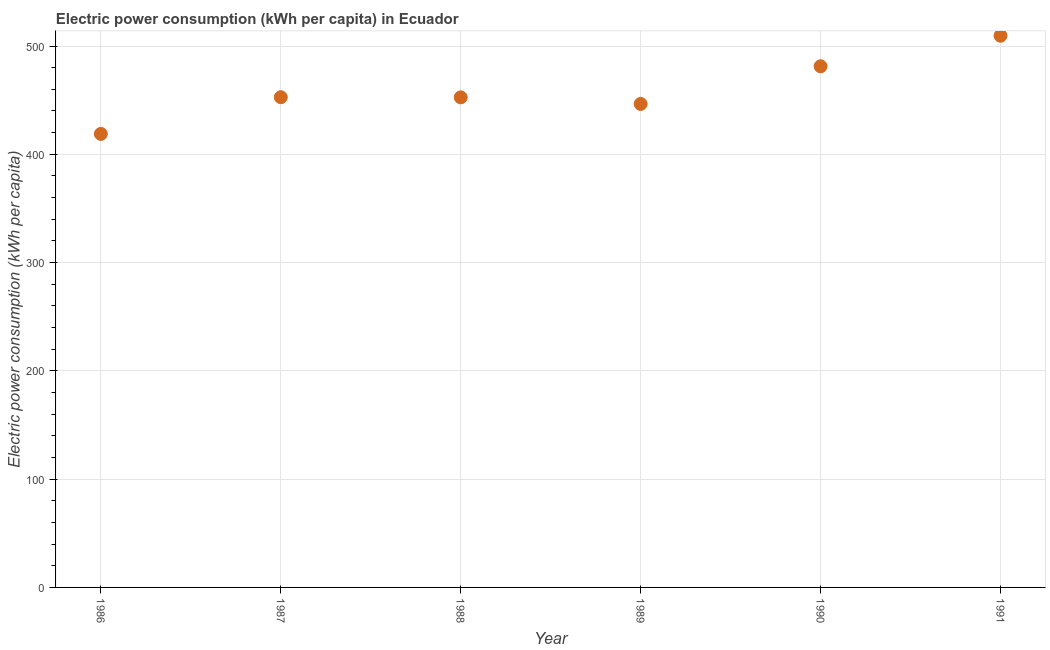What is the electric power consumption in 1990?
Provide a short and direct response. 481.3. Across all years, what is the maximum electric power consumption?
Your answer should be compact. 509.51. Across all years, what is the minimum electric power consumption?
Offer a very short reply. 418.85. In which year was the electric power consumption maximum?
Offer a terse response. 1991. In which year was the electric power consumption minimum?
Your answer should be compact. 1986. What is the sum of the electric power consumption?
Your answer should be compact. 2761.54. What is the difference between the electric power consumption in 1988 and 1990?
Your response must be concise. -28.7. What is the average electric power consumption per year?
Make the answer very short. 460.26. What is the median electric power consumption?
Give a very brief answer. 452.68. In how many years, is the electric power consumption greater than 440 kWh per capita?
Offer a terse response. 5. What is the ratio of the electric power consumption in 1988 to that in 1991?
Your response must be concise. 0.89. Is the electric power consumption in 1986 less than that in 1991?
Your response must be concise. Yes. Is the difference between the electric power consumption in 1986 and 1988 greater than the difference between any two years?
Provide a succinct answer. No. What is the difference between the highest and the second highest electric power consumption?
Your response must be concise. 28.21. Is the sum of the electric power consumption in 1987 and 1988 greater than the maximum electric power consumption across all years?
Offer a very short reply. Yes. What is the difference between the highest and the lowest electric power consumption?
Make the answer very short. 90.66. How many dotlines are there?
Your response must be concise. 1. Are the values on the major ticks of Y-axis written in scientific E-notation?
Give a very brief answer. No. What is the title of the graph?
Give a very brief answer. Electric power consumption (kWh per capita) in Ecuador. What is the label or title of the Y-axis?
Keep it short and to the point. Electric power consumption (kWh per capita). What is the Electric power consumption (kWh per capita) in 1986?
Offer a terse response. 418.85. What is the Electric power consumption (kWh per capita) in 1987?
Make the answer very short. 452.75. What is the Electric power consumption (kWh per capita) in 1988?
Keep it short and to the point. 452.6. What is the Electric power consumption (kWh per capita) in 1989?
Your answer should be very brief. 446.51. What is the Electric power consumption (kWh per capita) in 1990?
Offer a very short reply. 481.3. What is the Electric power consumption (kWh per capita) in 1991?
Offer a terse response. 509.51. What is the difference between the Electric power consumption (kWh per capita) in 1986 and 1987?
Ensure brevity in your answer.  -33.9. What is the difference between the Electric power consumption (kWh per capita) in 1986 and 1988?
Your answer should be compact. -33.75. What is the difference between the Electric power consumption (kWh per capita) in 1986 and 1989?
Your answer should be very brief. -27.66. What is the difference between the Electric power consumption (kWh per capita) in 1986 and 1990?
Make the answer very short. -62.45. What is the difference between the Electric power consumption (kWh per capita) in 1986 and 1991?
Make the answer very short. -90.66. What is the difference between the Electric power consumption (kWh per capita) in 1987 and 1988?
Ensure brevity in your answer.  0.15. What is the difference between the Electric power consumption (kWh per capita) in 1987 and 1989?
Your response must be concise. 6.24. What is the difference between the Electric power consumption (kWh per capita) in 1987 and 1990?
Give a very brief answer. -28.55. What is the difference between the Electric power consumption (kWh per capita) in 1987 and 1991?
Your answer should be compact. -56.76. What is the difference between the Electric power consumption (kWh per capita) in 1988 and 1989?
Keep it short and to the point. 6.09. What is the difference between the Electric power consumption (kWh per capita) in 1988 and 1990?
Your response must be concise. -28.7. What is the difference between the Electric power consumption (kWh per capita) in 1988 and 1991?
Keep it short and to the point. -56.91. What is the difference between the Electric power consumption (kWh per capita) in 1989 and 1990?
Keep it short and to the point. -34.79. What is the difference between the Electric power consumption (kWh per capita) in 1989 and 1991?
Your answer should be compact. -63. What is the difference between the Electric power consumption (kWh per capita) in 1990 and 1991?
Give a very brief answer. -28.21. What is the ratio of the Electric power consumption (kWh per capita) in 1986 to that in 1987?
Make the answer very short. 0.93. What is the ratio of the Electric power consumption (kWh per capita) in 1986 to that in 1988?
Provide a short and direct response. 0.93. What is the ratio of the Electric power consumption (kWh per capita) in 1986 to that in 1989?
Provide a short and direct response. 0.94. What is the ratio of the Electric power consumption (kWh per capita) in 1986 to that in 1990?
Provide a succinct answer. 0.87. What is the ratio of the Electric power consumption (kWh per capita) in 1986 to that in 1991?
Offer a terse response. 0.82. What is the ratio of the Electric power consumption (kWh per capita) in 1987 to that in 1990?
Your response must be concise. 0.94. What is the ratio of the Electric power consumption (kWh per capita) in 1987 to that in 1991?
Give a very brief answer. 0.89. What is the ratio of the Electric power consumption (kWh per capita) in 1988 to that in 1991?
Your answer should be very brief. 0.89. What is the ratio of the Electric power consumption (kWh per capita) in 1989 to that in 1990?
Provide a short and direct response. 0.93. What is the ratio of the Electric power consumption (kWh per capita) in 1989 to that in 1991?
Your response must be concise. 0.88. What is the ratio of the Electric power consumption (kWh per capita) in 1990 to that in 1991?
Keep it short and to the point. 0.94. 